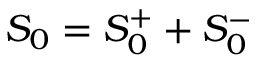<formula> <loc_0><loc_0><loc_500><loc_500>S _ { 0 } = S _ { 0 } ^ { + } + S _ { 0 } ^ { - }</formula> 